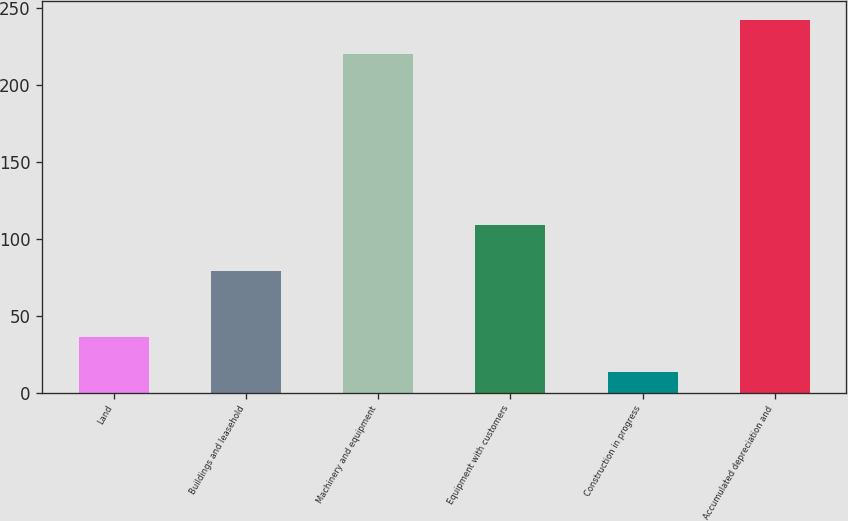Convert chart to OTSL. <chart><loc_0><loc_0><loc_500><loc_500><bar_chart><fcel>Land<fcel>Buildings and leasehold<fcel>Machinery and equipment<fcel>Equipment with customers<fcel>Construction in progress<fcel>Accumulated depreciation and<nl><fcel>35.81<fcel>78.7<fcel>219.7<fcel>108.5<fcel>13.5<fcel>242.01<nl></chart> 